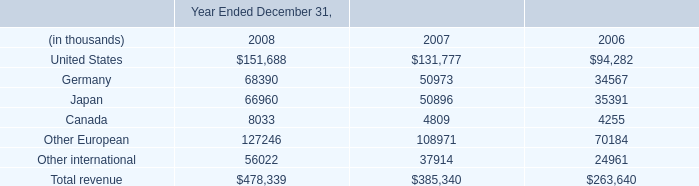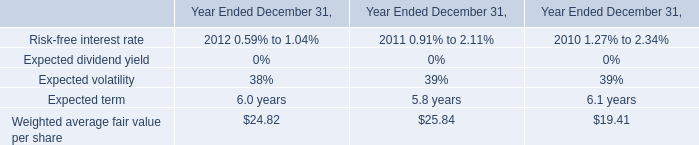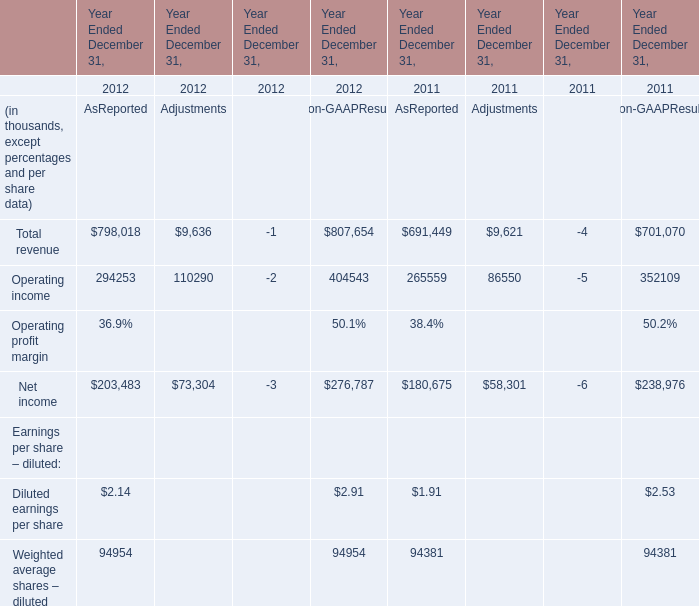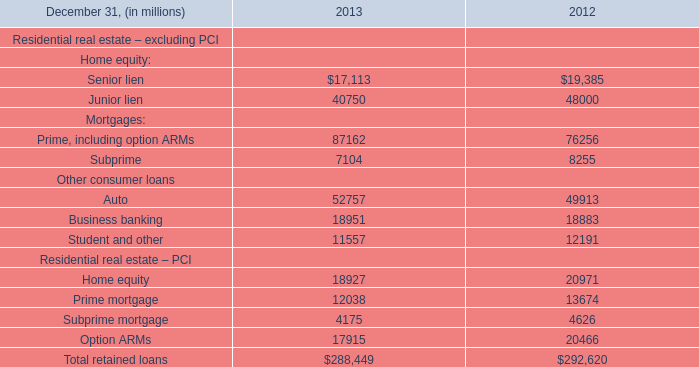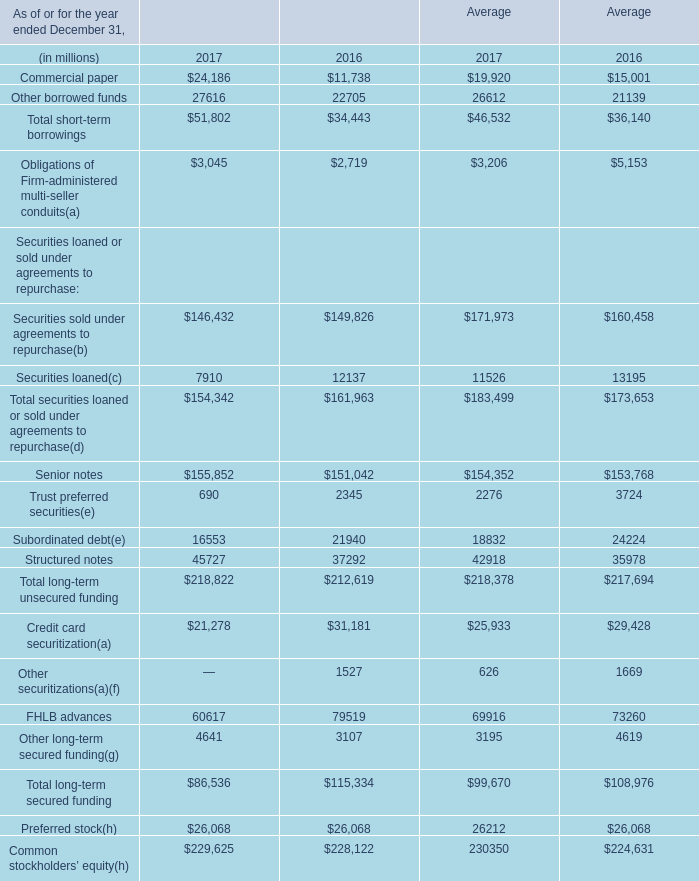What is the total amount of Commercial paper of Average 2017, and Home equity Residential real estate – PCI of 2012 ? 
Computations: (19920.0 + 20971.0)
Answer: 40891.0. 